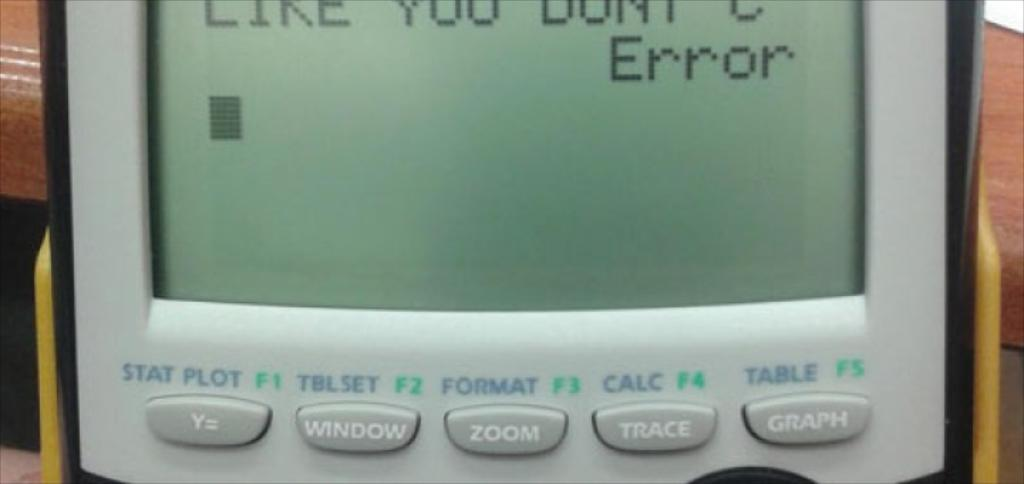Provide a one-sentence caption for the provided image. A calculator displays the word "Error" on the screen. 